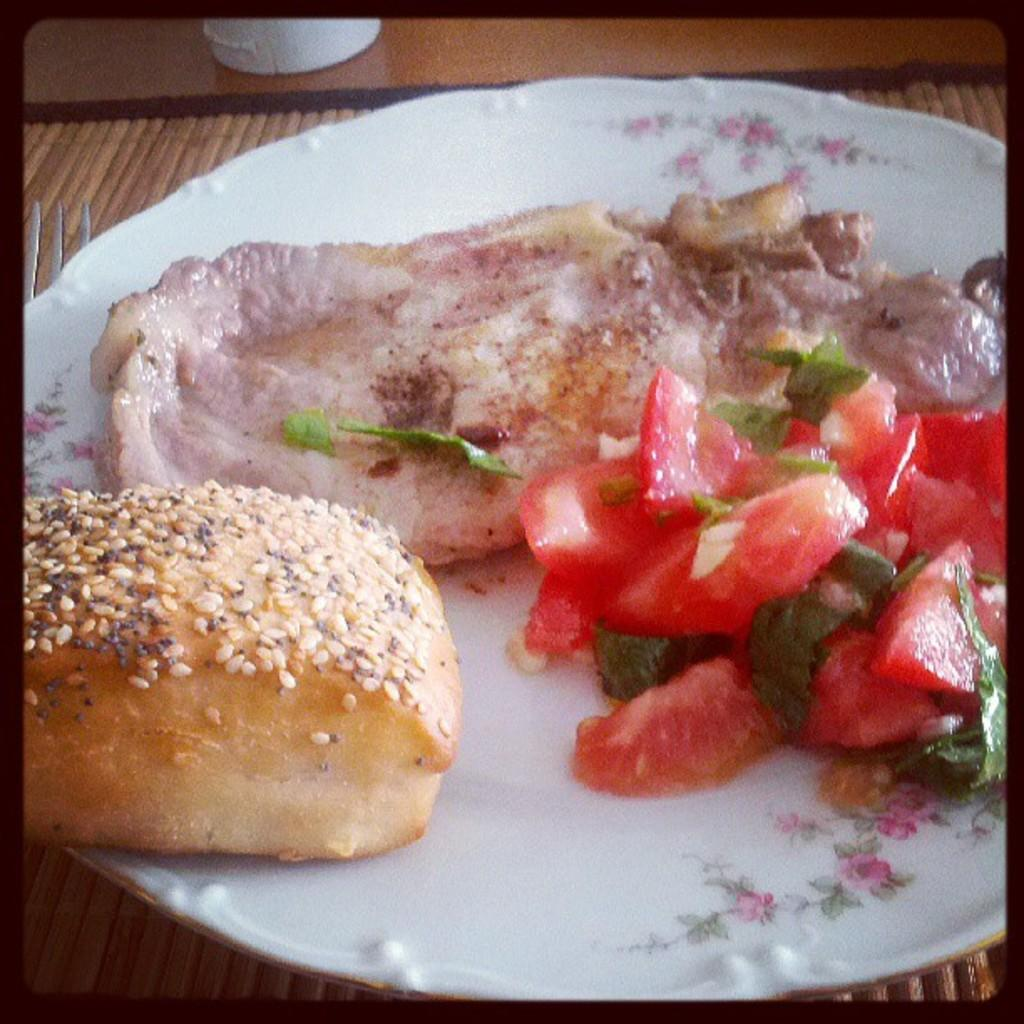What object is present in the image that is typically used for serving food? There is a plate in the image. What color is the plate? The plate is white in color. What can be found on the plate? There are food items on the plate. What route does the robin take to reach the plate in the image? There is no robin present in the image, so it is not possible to determine a route. 